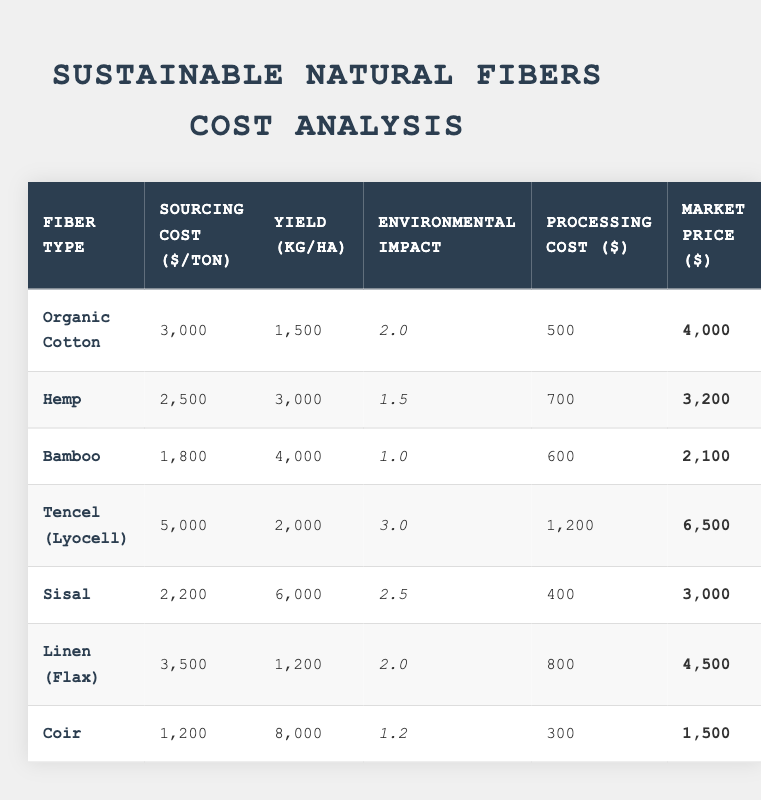What is the sourcing cost per ton of Bamboo? From the table, the sourcing cost per ton for Bamboo is found in the respective cell, which lists the value.
Answer: 1800 Which fiber has the highest average yield per hectare? By examining the yield column, Coir shows 8000 kg/ha, which is greater than all the other fibers listed.
Answer: Coir What is the difference in market price between Tencel and Hemp? The market price for Tencel is 6500, and for Hemp it is 3200. The difference is calculated as 6500 - 3200 = 3300.
Answer: 3300 Is the environmental impact score for Organic Cotton less than 3? The environmental impact score for Organic Cotton is 2, which is indeed less than 3.
Answer: Yes What is the average sourcing cost per ton for all fibers listed? The sourcing costs are 3000 + 2500 + 1800 + 5000 + 2200 + 3500 + 1200 = 19200 for 7 fibers. The average is 19200 / 7 = approximately 2742.86.
Answer: 2742.86 What fiber type has the lowest processing cost, and what is that cost? Reviewing the processing costs, Coir has the lowest processing cost of 300.
Answer: Coir; 300 How many fibers have an environmental impact score of less than 2? The fibers with scores less than 2 are Bamboo (1.0) and Coir (1.2). Therefore, there are 2 fibers.
Answer: 2 If you were to compare the total cost (sourcing + processing) for each fiber, which fiber has the highest total cost? Total costs are: Organic Cotton: 3500, Hemp: 3200, Bamboo: 2400, Tencel: 6200, Sisal: 2600, Linen: 4300, Coir: 1500. Tencel has the highest total cost.
Answer: Tencel What is the market price to sourcing cost ratio for Sisal? The ratio is calculated: market price (3000) divided by sourcing cost (2200) gives a ratio of approximately 1.36.
Answer: 1.36 Which fiber type has the second lowest environmental impact score? Listing the environmental impact scores: Bamboo (1.0), Coir (1.2), Hemp (1.5), Organic Cotton (2.0), Sisal (2.5), Linen (2.0), Tencel (3.0). With 1.2, Coir ranks second lowest.
Answer: Coir 